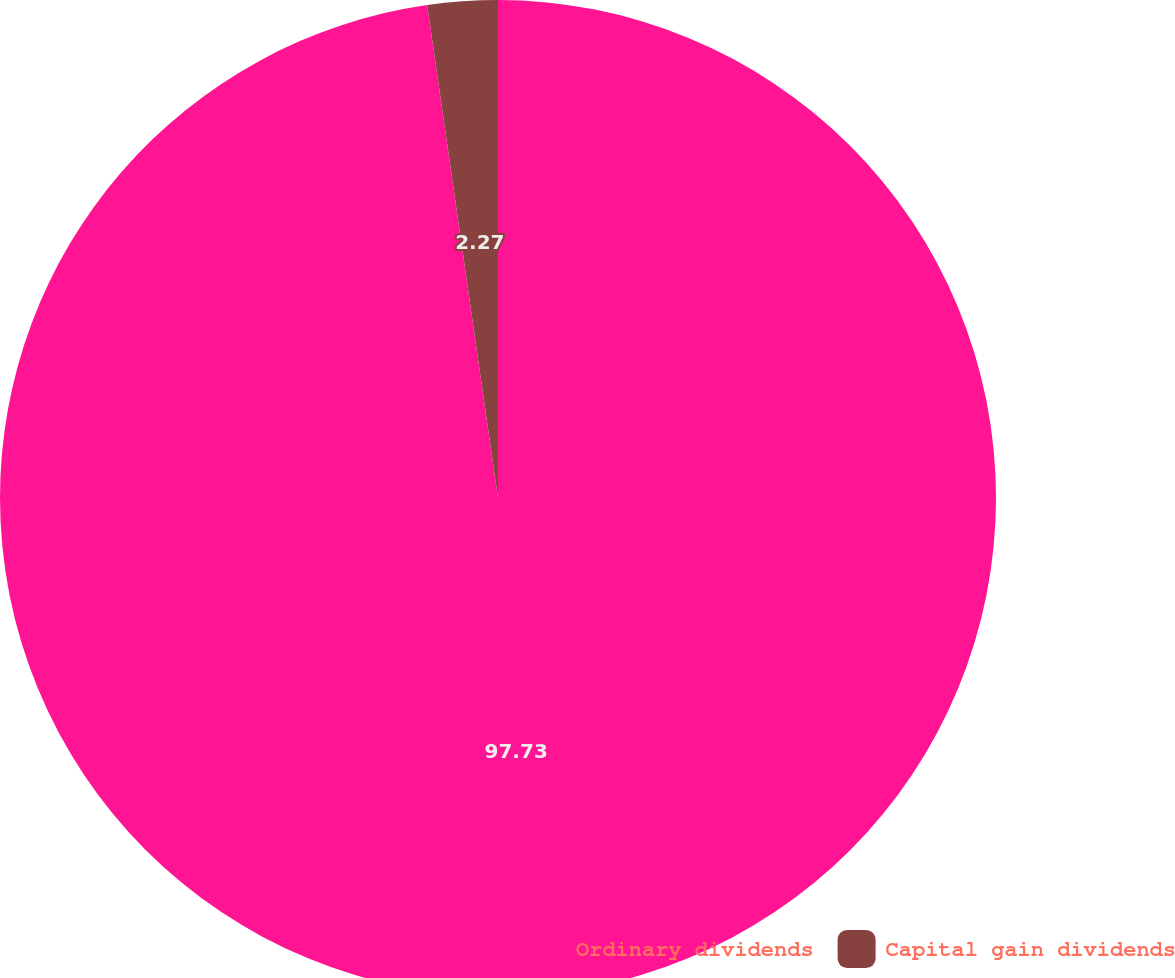<chart> <loc_0><loc_0><loc_500><loc_500><pie_chart><fcel>Ordinary dividends<fcel>Capital gain dividends<nl><fcel>97.73%<fcel>2.27%<nl></chart> 